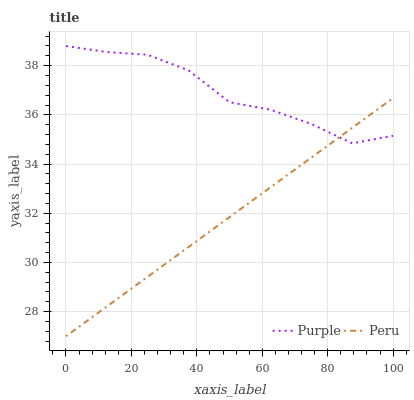Does Peru have the minimum area under the curve?
Answer yes or no. Yes. Does Purple have the maximum area under the curve?
Answer yes or no. Yes. Does Peru have the maximum area under the curve?
Answer yes or no. No. Is Peru the smoothest?
Answer yes or no. Yes. Is Purple the roughest?
Answer yes or no. Yes. Is Peru the roughest?
Answer yes or no. No. Does Peru have the lowest value?
Answer yes or no. Yes. Does Purple have the highest value?
Answer yes or no. Yes. Does Peru have the highest value?
Answer yes or no. No. Does Peru intersect Purple?
Answer yes or no. Yes. Is Peru less than Purple?
Answer yes or no. No. Is Peru greater than Purple?
Answer yes or no. No. 